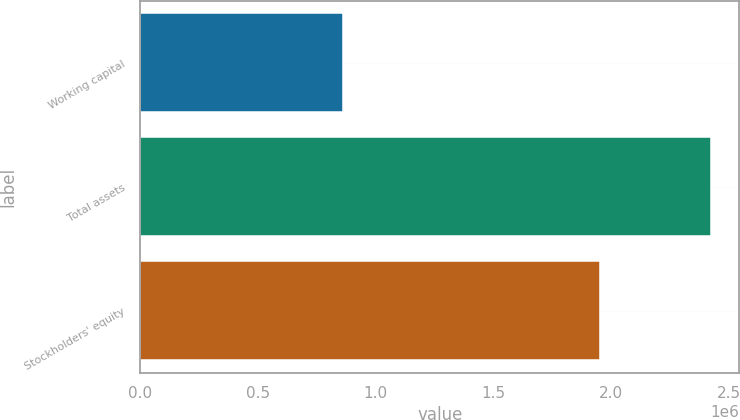<chart> <loc_0><loc_0><loc_500><loc_500><bar_chart><fcel>Working capital<fcel>Total assets<fcel>Stockholders' equity<nl><fcel>861448<fcel>2.42168e+06<fcel>1.95074e+06<nl></chart> 